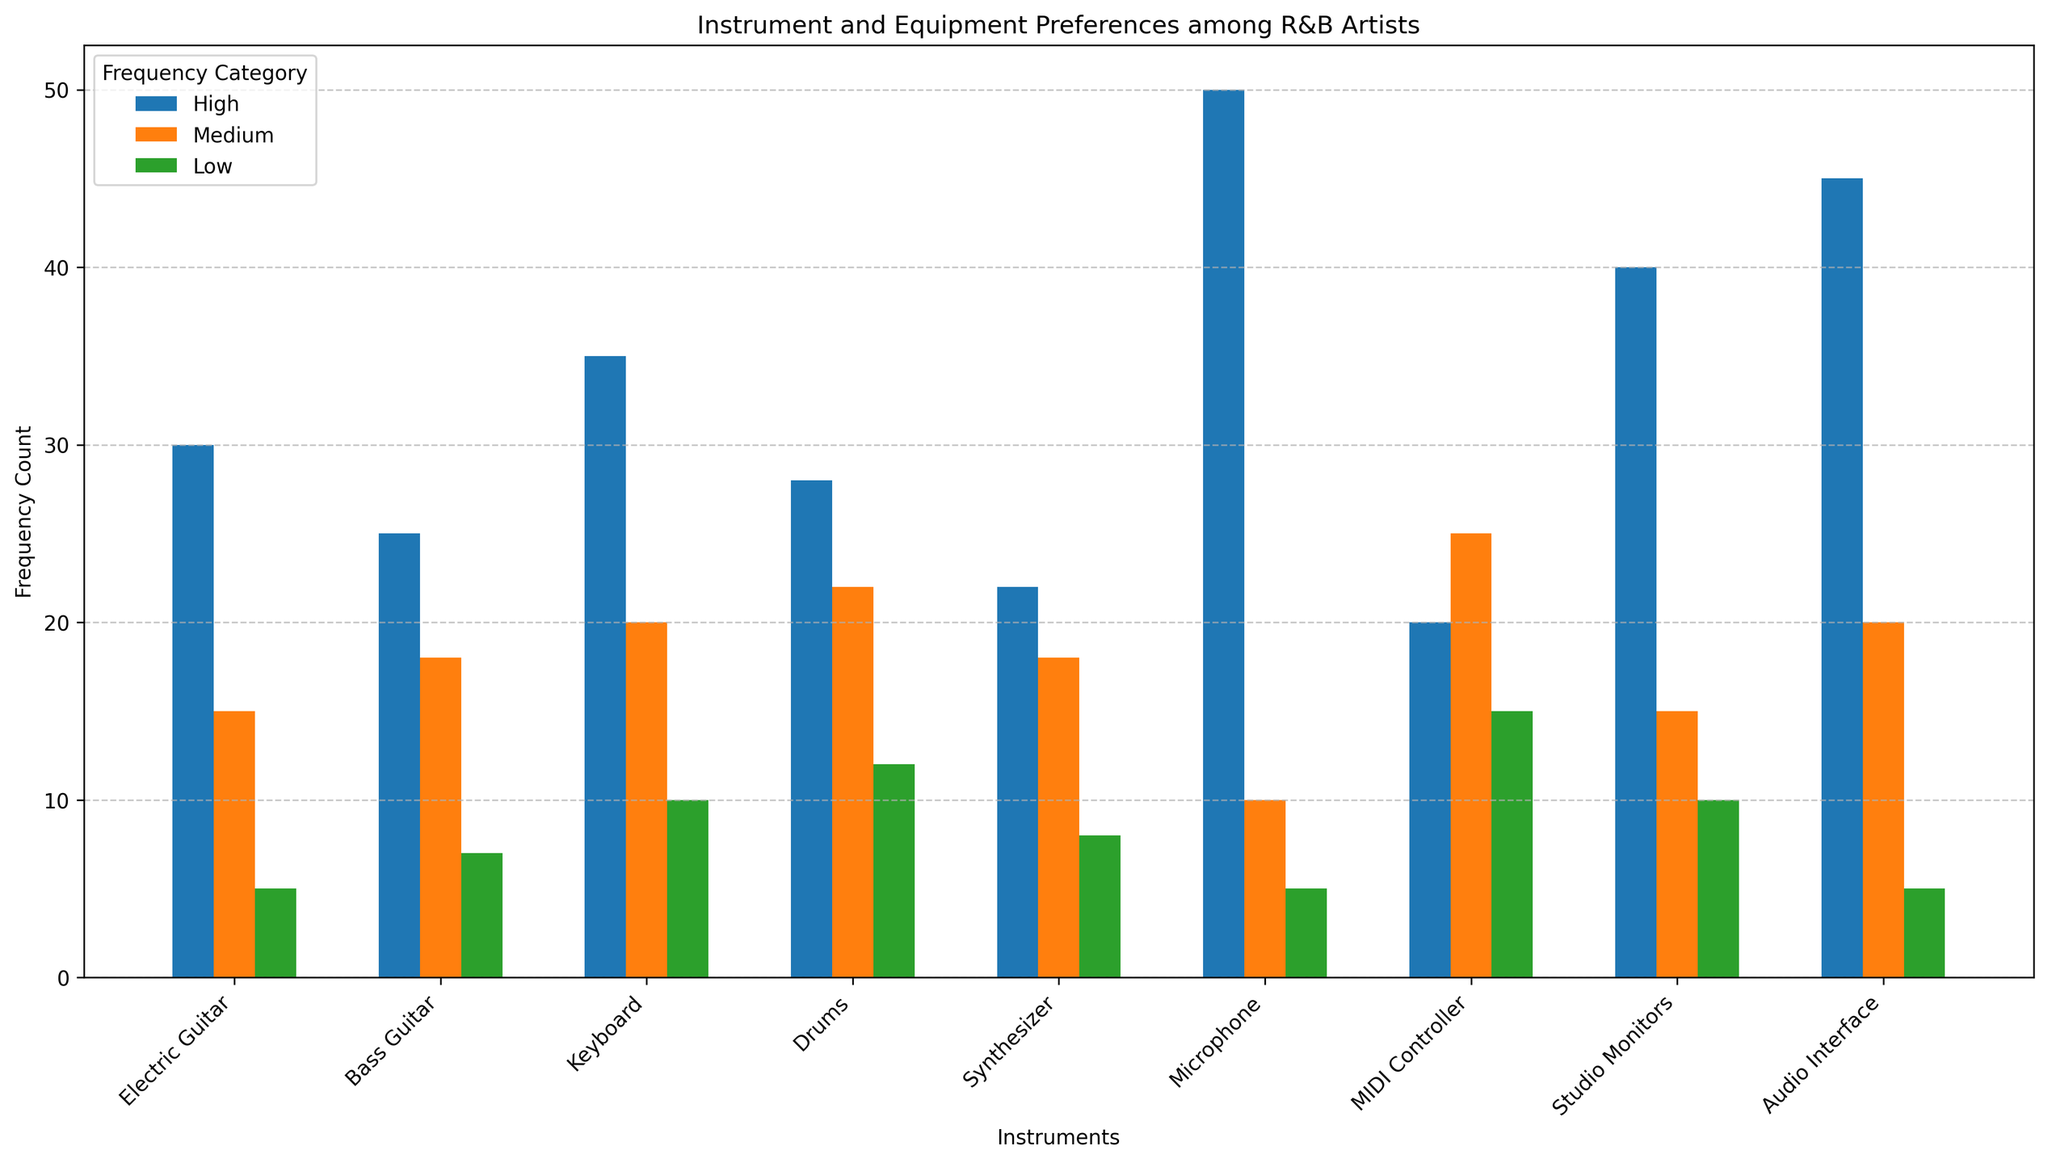Which instrument has the highest usage in the 'High' frequency category? To answer this, we look at the height of the red bars, which represent the 'High' frequency category, and identify the tallest bar among all the instruments. The tallest red bar corresponds to the Microphone with a count of 50.
Answer: Microphone Which equipment has the lowest usage in the 'Medium' frequency category? To find this, check the heights of the green bars, which represent the 'Medium' frequency category, and identify the shortest bar among all the instruments and equipment. The shortest green bar corresponds to the Microphone with a count of 10.
Answer: Microphone What is the total usage count for the Drums across all frequency categories? We add up the counts for the Drums across the 'High', 'Medium', and 'Low' frequency categories. These are 28 (High), 22 (Medium), and 12 (Low). Summing these gives: 28 + 22 + 12.
Answer: 62 Which instrument has a higher 'Medium' usage count: Bass Guitar or Synthesizer? Compare the heights of the green bars representing the 'Medium' frequency category for Bass Guitar and Synthesizer. The Bass Guitar has a count of 18 while the Synthesizer also has a count of 18. Thus, they are equal.
Answer: They are equal Which has more 'High' frequency usage: Studio Monitors or Audio Interface? Compare the heights of the red bars representing the 'High' frequency category for Studio Monitors and Audio Interface. The Studio Monitors have a count of 40 while the Audio Interface has a count of 45. The Audio Interface has a higher count.
Answer: Audio Interface What is the average 'Low' frequency usage for Electric Guitar and Keyboard? First, find the 'Low' frequency counts for Electric Guitar and Keyboard, which are 5 and 10 respectively. Then calculate the average by adding them and dividing by 2: (5 + 10) / 2.
Answer: 7.5 Which instrument or equipment has the highest total usage count when summing across all frequency categories? Sum the counts across 'High', 'Medium', and 'Low' for each instrument and equipment, and identify the highest total sum. For example, Microphone: 50 (High) + 10 (Medium) + 5 (Low) = 65, which is the highest.
Answer: Microphone How much greater is the 'High' frequency usage of the Keyboard compared to the Synthesizer? The 'High' frequency count for Keyboard is 35 and for Synthesizer is 22. Calculate the difference: 35 - 22.
Answer: 13 What proportion of the total usage of Synthesizer is in the 'High' frequency category? Sum the 'High', 'Medium', and 'Low' frequency counts for Synthesizer: 22 (High) + 18 (Medium) + 8 (Low) = 48. Then, calculate the proportion: 22 (High) / 48 (Total).
Answer: 22/48 or approximately 0.458 or 45.8% Which has the highest 'Low' frequency usage count: MIDI Controller or Studio Monitors? Compare the heights of the blue bars representing the 'Low' frequency category for MIDI Controller and Studio Monitors. The MIDI Controller has a count of 15 while the Studio Monitors have a count of 10. The MIDI Controller has a higher count.
Answer: MIDI Controller 